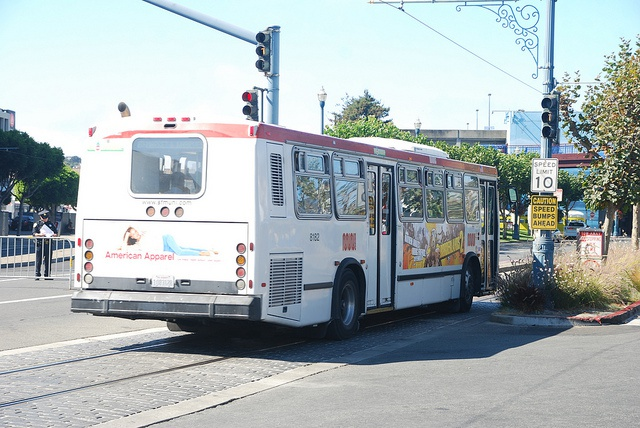Describe the objects in this image and their specific colors. I can see bus in lightblue, white, darkgray, gray, and black tones, people in lightblue, black, lightgray, navy, and gray tones, traffic light in lightblue, navy, black, blue, and gray tones, traffic light in lightblue, navy, blue, and gray tones, and traffic light in lightblue, gray, blue, white, and darkgray tones in this image. 